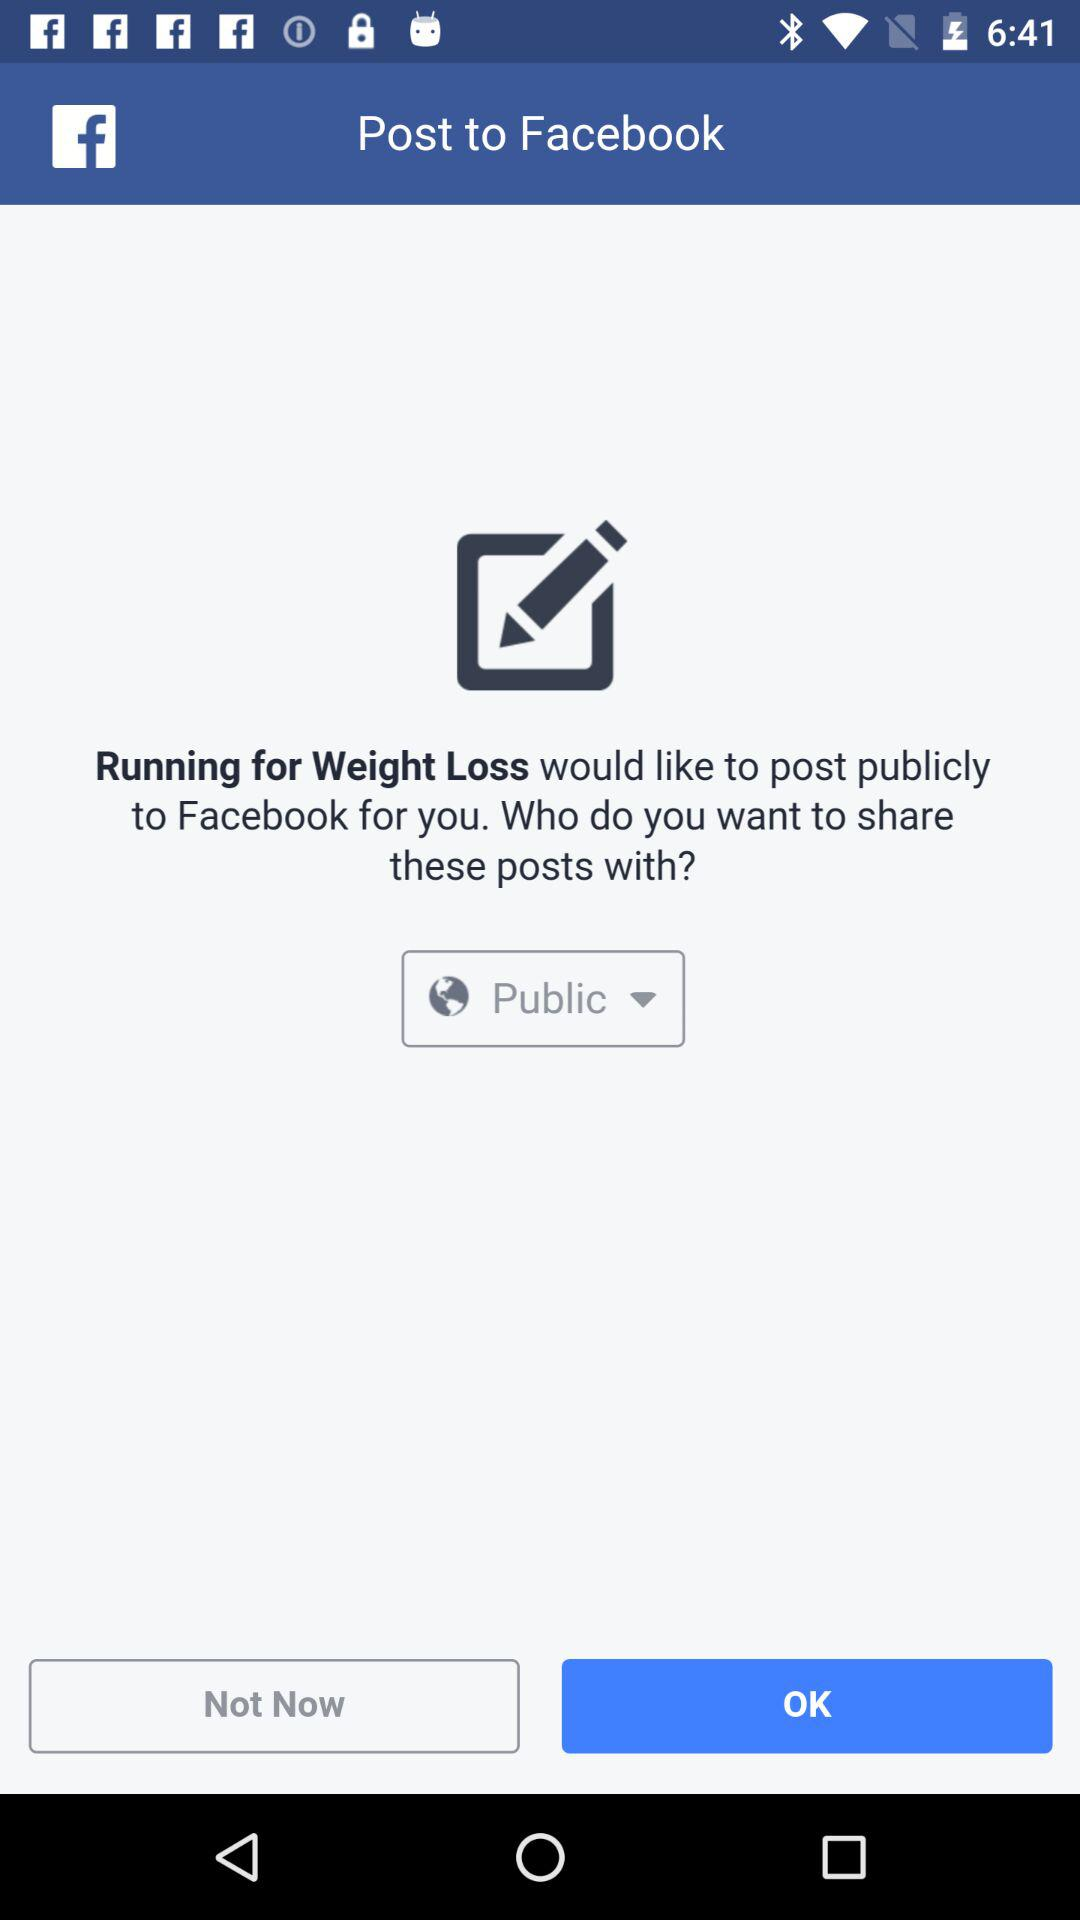What is the application name? The application name is "Running for Weight Loss". 